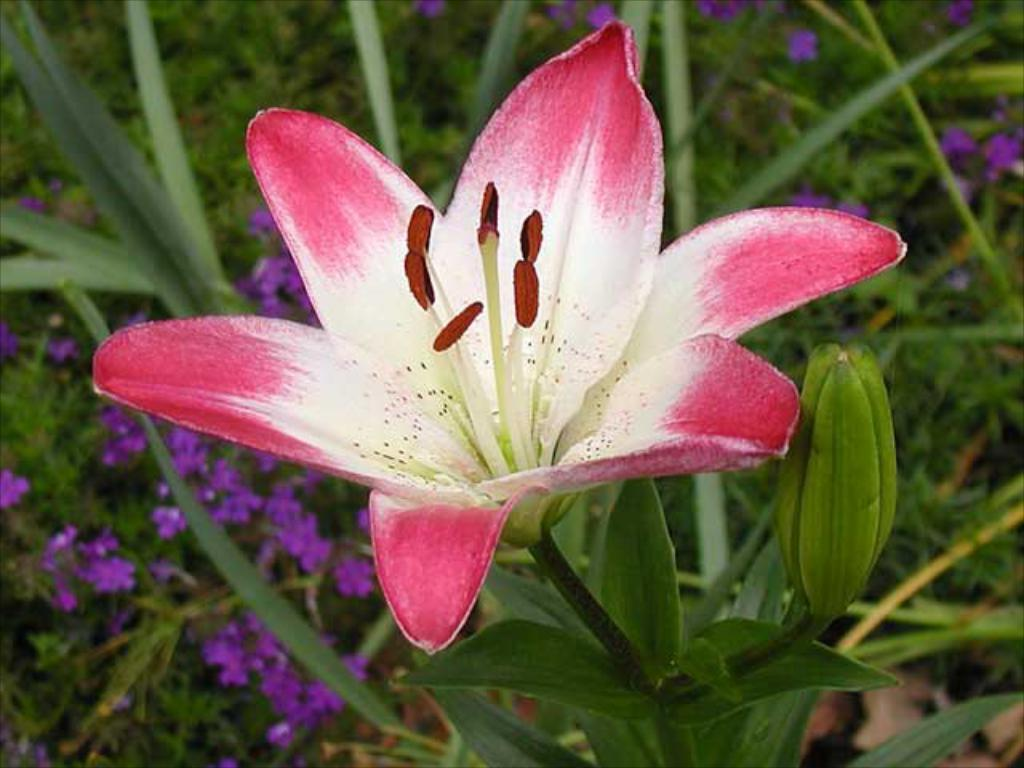What is the main subject of the image? The main subject of the image is a stem with leaves. What features can be observed on the stem? The stem has a bud and a flower in the image. What colors are present in the flower? The flower is white and pink in color. What can be seen in the background of the image? There are leaves and violet color flowers in the background of the image. What is the chance of the toe being present in the image? There is no toe present in the image; it is a stem with leaves, a bud, and a flower. Can you control the growth of the violet flowers in the background of the image? The growth of the violet flowers in the background of the image cannot be controlled from the image itself, as it is a static representation. 